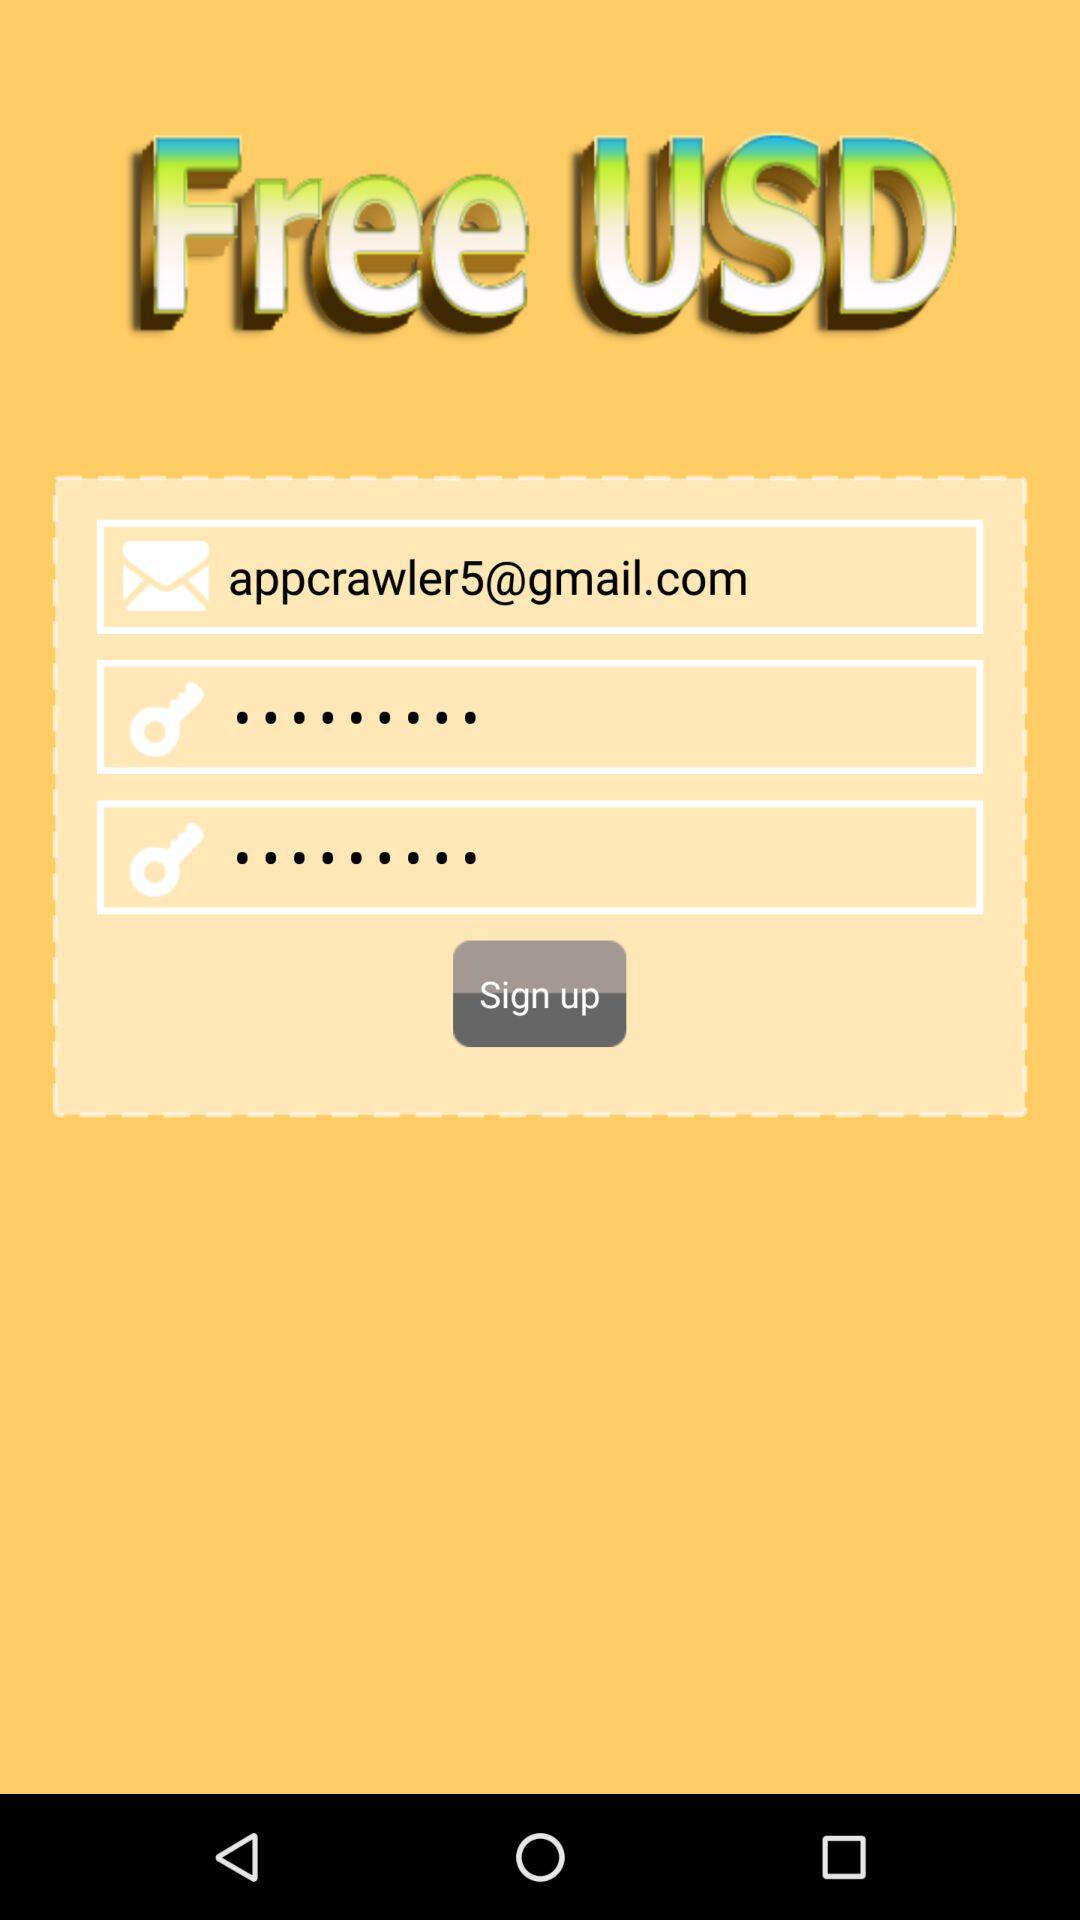What is the email address? The email address is appcrawler5@gmail.com. 